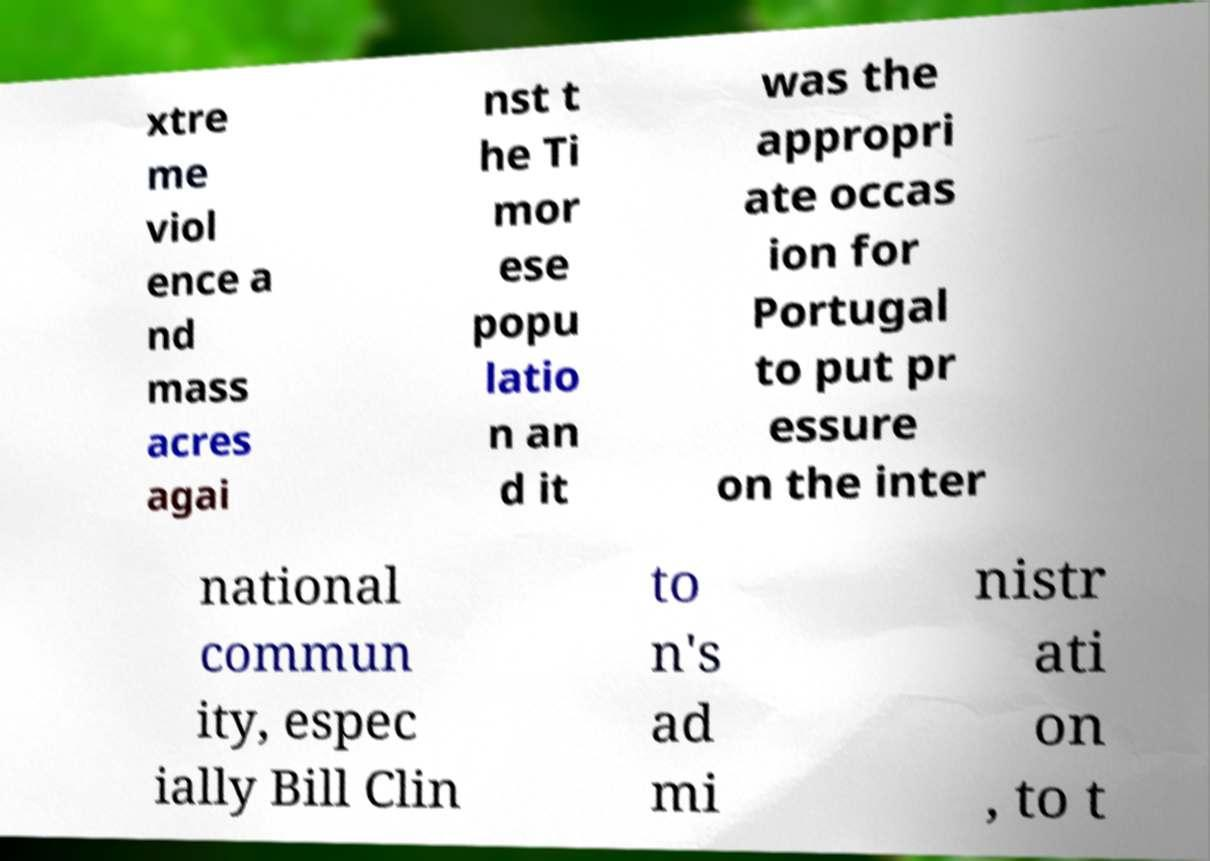Can you accurately transcribe the text from the provided image for me? xtre me viol ence a nd mass acres agai nst t he Ti mor ese popu latio n an d it was the appropri ate occas ion for Portugal to put pr essure on the inter national commun ity, espec ially Bill Clin to n's ad mi nistr ati on , to t 